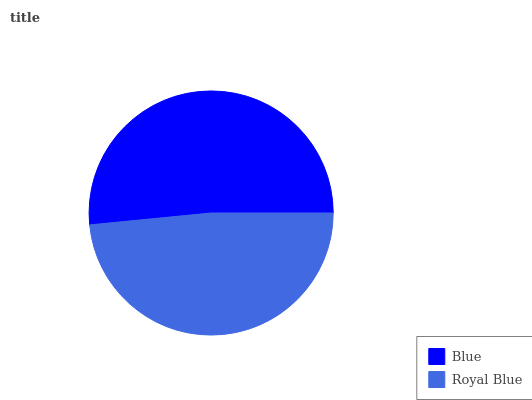Is Royal Blue the minimum?
Answer yes or no. Yes. Is Blue the maximum?
Answer yes or no. Yes. Is Royal Blue the maximum?
Answer yes or no. No. Is Blue greater than Royal Blue?
Answer yes or no. Yes. Is Royal Blue less than Blue?
Answer yes or no. Yes. Is Royal Blue greater than Blue?
Answer yes or no. No. Is Blue less than Royal Blue?
Answer yes or no. No. Is Blue the high median?
Answer yes or no. Yes. Is Royal Blue the low median?
Answer yes or no. Yes. Is Royal Blue the high median?
Answer yes or no. No. Is Blue the low median?
Answer yes or no. No. 